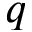Convert formula to latex. <formula><loc_0><loc_0><loc_500><loc_500>q</formula> 